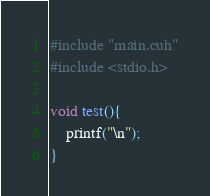Convert code to text. <code><loc_0><loc_0><loc_500><loc_500><_Cuda_>

#include "main.cuh"
#include <stdio.h>

void test(){
    printf("\n");
}</code> 